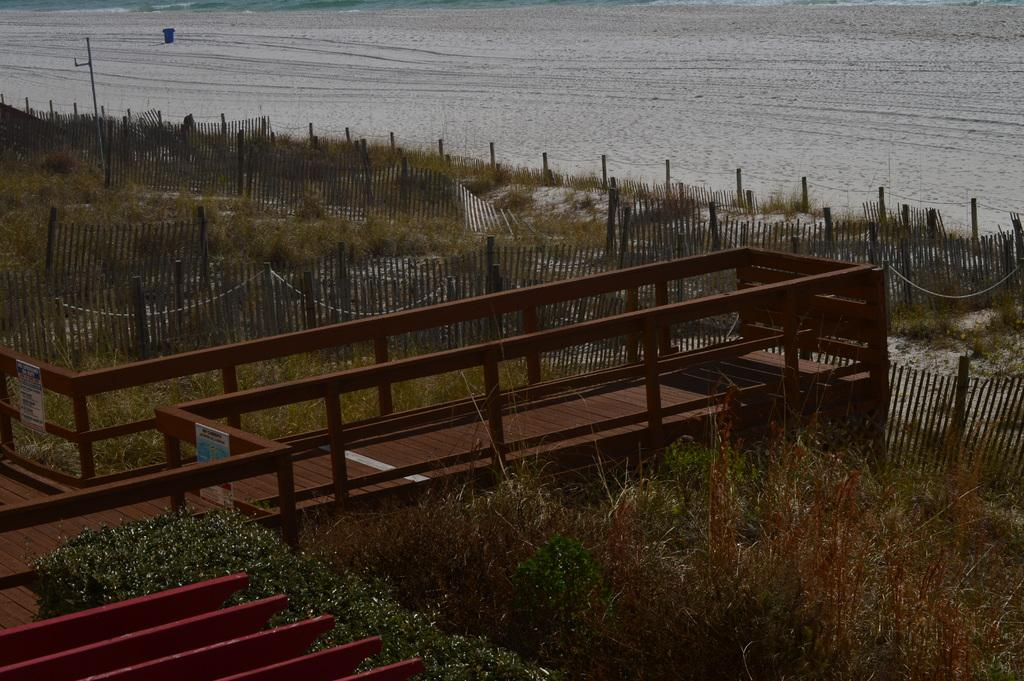What type of vegetation is present in the front of the image? There is dry grass in the front of the image. What else can be seen in the image besides the dry grass? There are plants in the image. What can be seen in the background of the image? There is water visible in the background of the image. What is located in the center of the image? There is a fence and a pole in the center of the image. What type of structure is present in the image? There is a bridge in the image. What type of mine can be seen in the image? There is no mine present in the image. Is the queen visible in the image? There is no queen present in the image. 